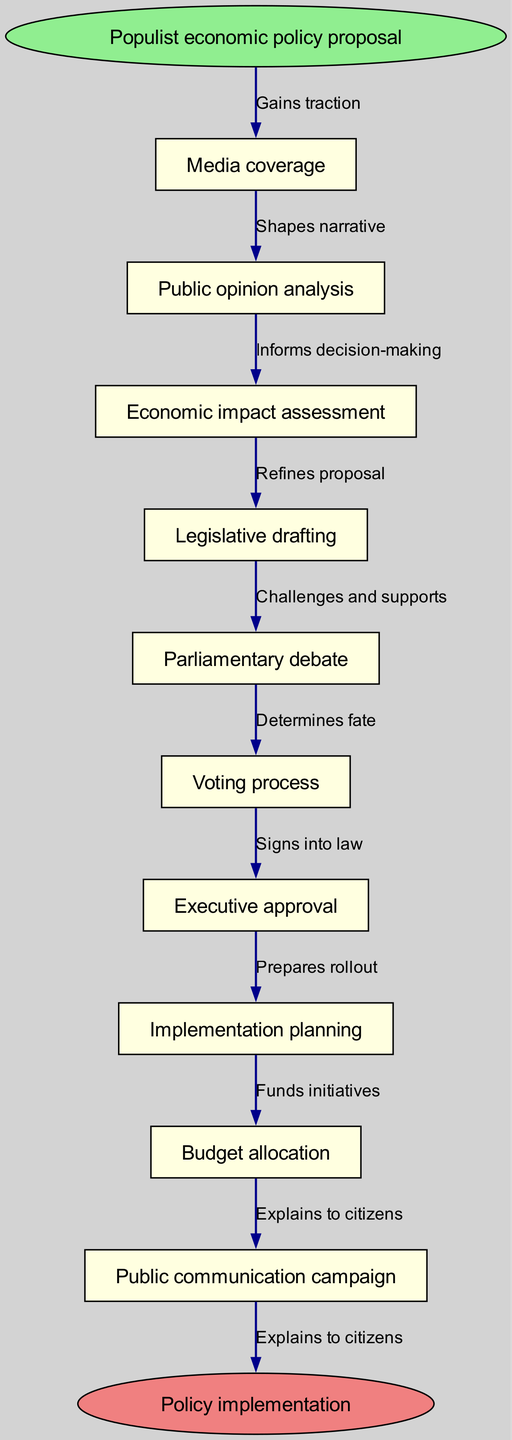What is the starting point of the process? The flow chart begins with "Populist economic policy proposal", which is indicated as the first node before any other nodes are connected.
Answer: Populist economic policy proposal How many intermediate nodes are there? The intermediate nodes listed in the diagram amount to ten total nodes, which are the steps following the initial proposal.
Answer: 10 What is the last step before implementation? The step just before the "Policy implementation" node is "Public communication campaign", which effectively leads to informing the public about the policy.
Answer: Public communication campaign What influences public opinion analysis? The node "Media coverage" influences public opinion analysis by providing the necessary attention that can sway public sentiment about the policy.
Answer: Media coverage What describes the connection between "Legislative drafting" and "Parliamentary debate"? The relationship is characterized by the edge labeled "Refines proposal", indicating that the drafting stage shapes and improves the proposal through debate.
Answer: Refines proposal Which node directly follows the "Voting process"? The node that comes after "Voting process" in the flow is "Executive approval", which signifies the subsequent stage in which the executive must approve the legislation.
Answer: Executive approval What shape is used for the start and end nodes? Both the start node, which is the proposal, and the end node, which indicates policy implementation, are shaped as ovals.
Answer: Oval How many edges connect the nodes? The flow chart has a total of nine edges. Each edge connects two nodes, describing the relationships and transitions from one stage to another.
Answer: 9 What is the purpose of the "Economic impact assessment" node? The "Economic impact assessment" node serves to evaluate the potential consequences of the proposed policy, which informs subsequent decision-making.
Answer: Informs decision-making 